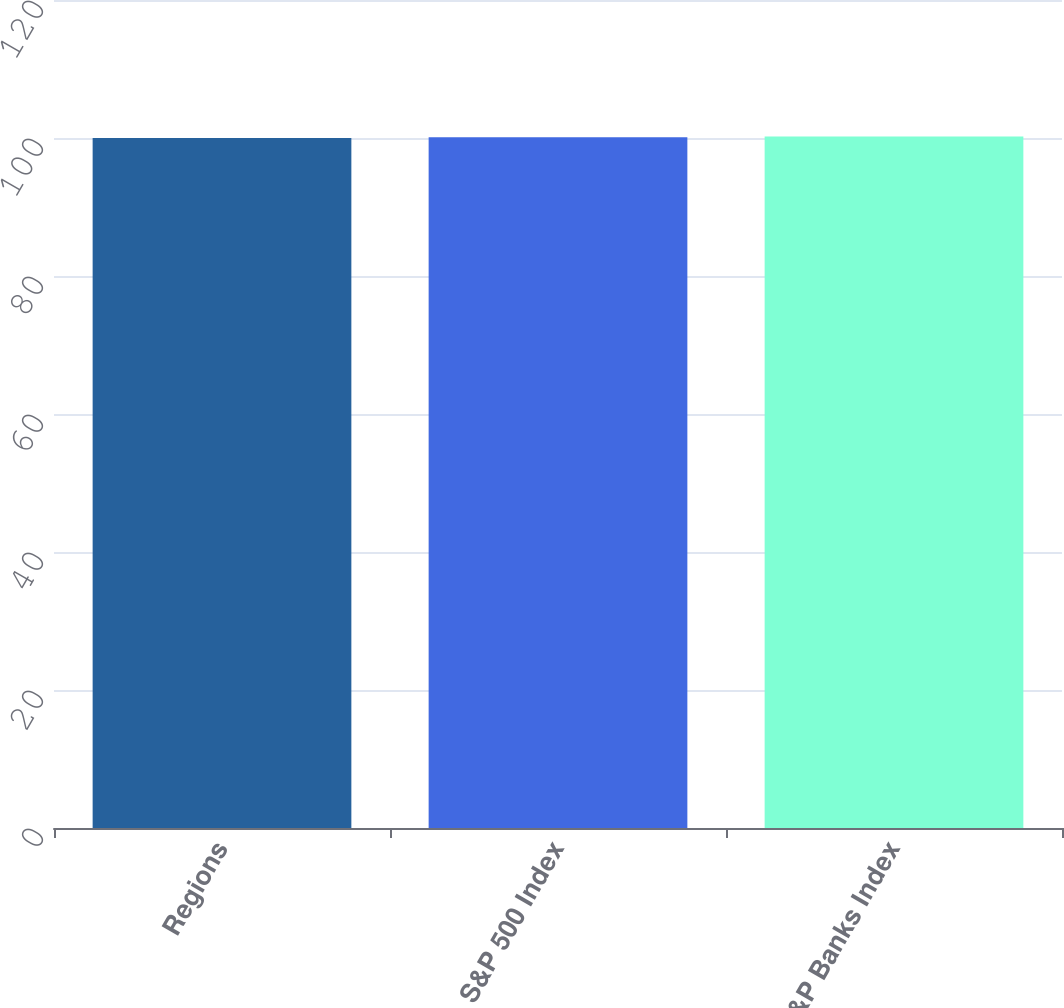Convert chart to OTSL. <chart><loc_0><loc_0><loc_500><loc_500><bar_chart><fcel>Regions<fcel>S&P 500 Index<fcel>S&P Banks Index<nl><fcel>100<fcel>100.1<fcel>100.2<nl></chart> 